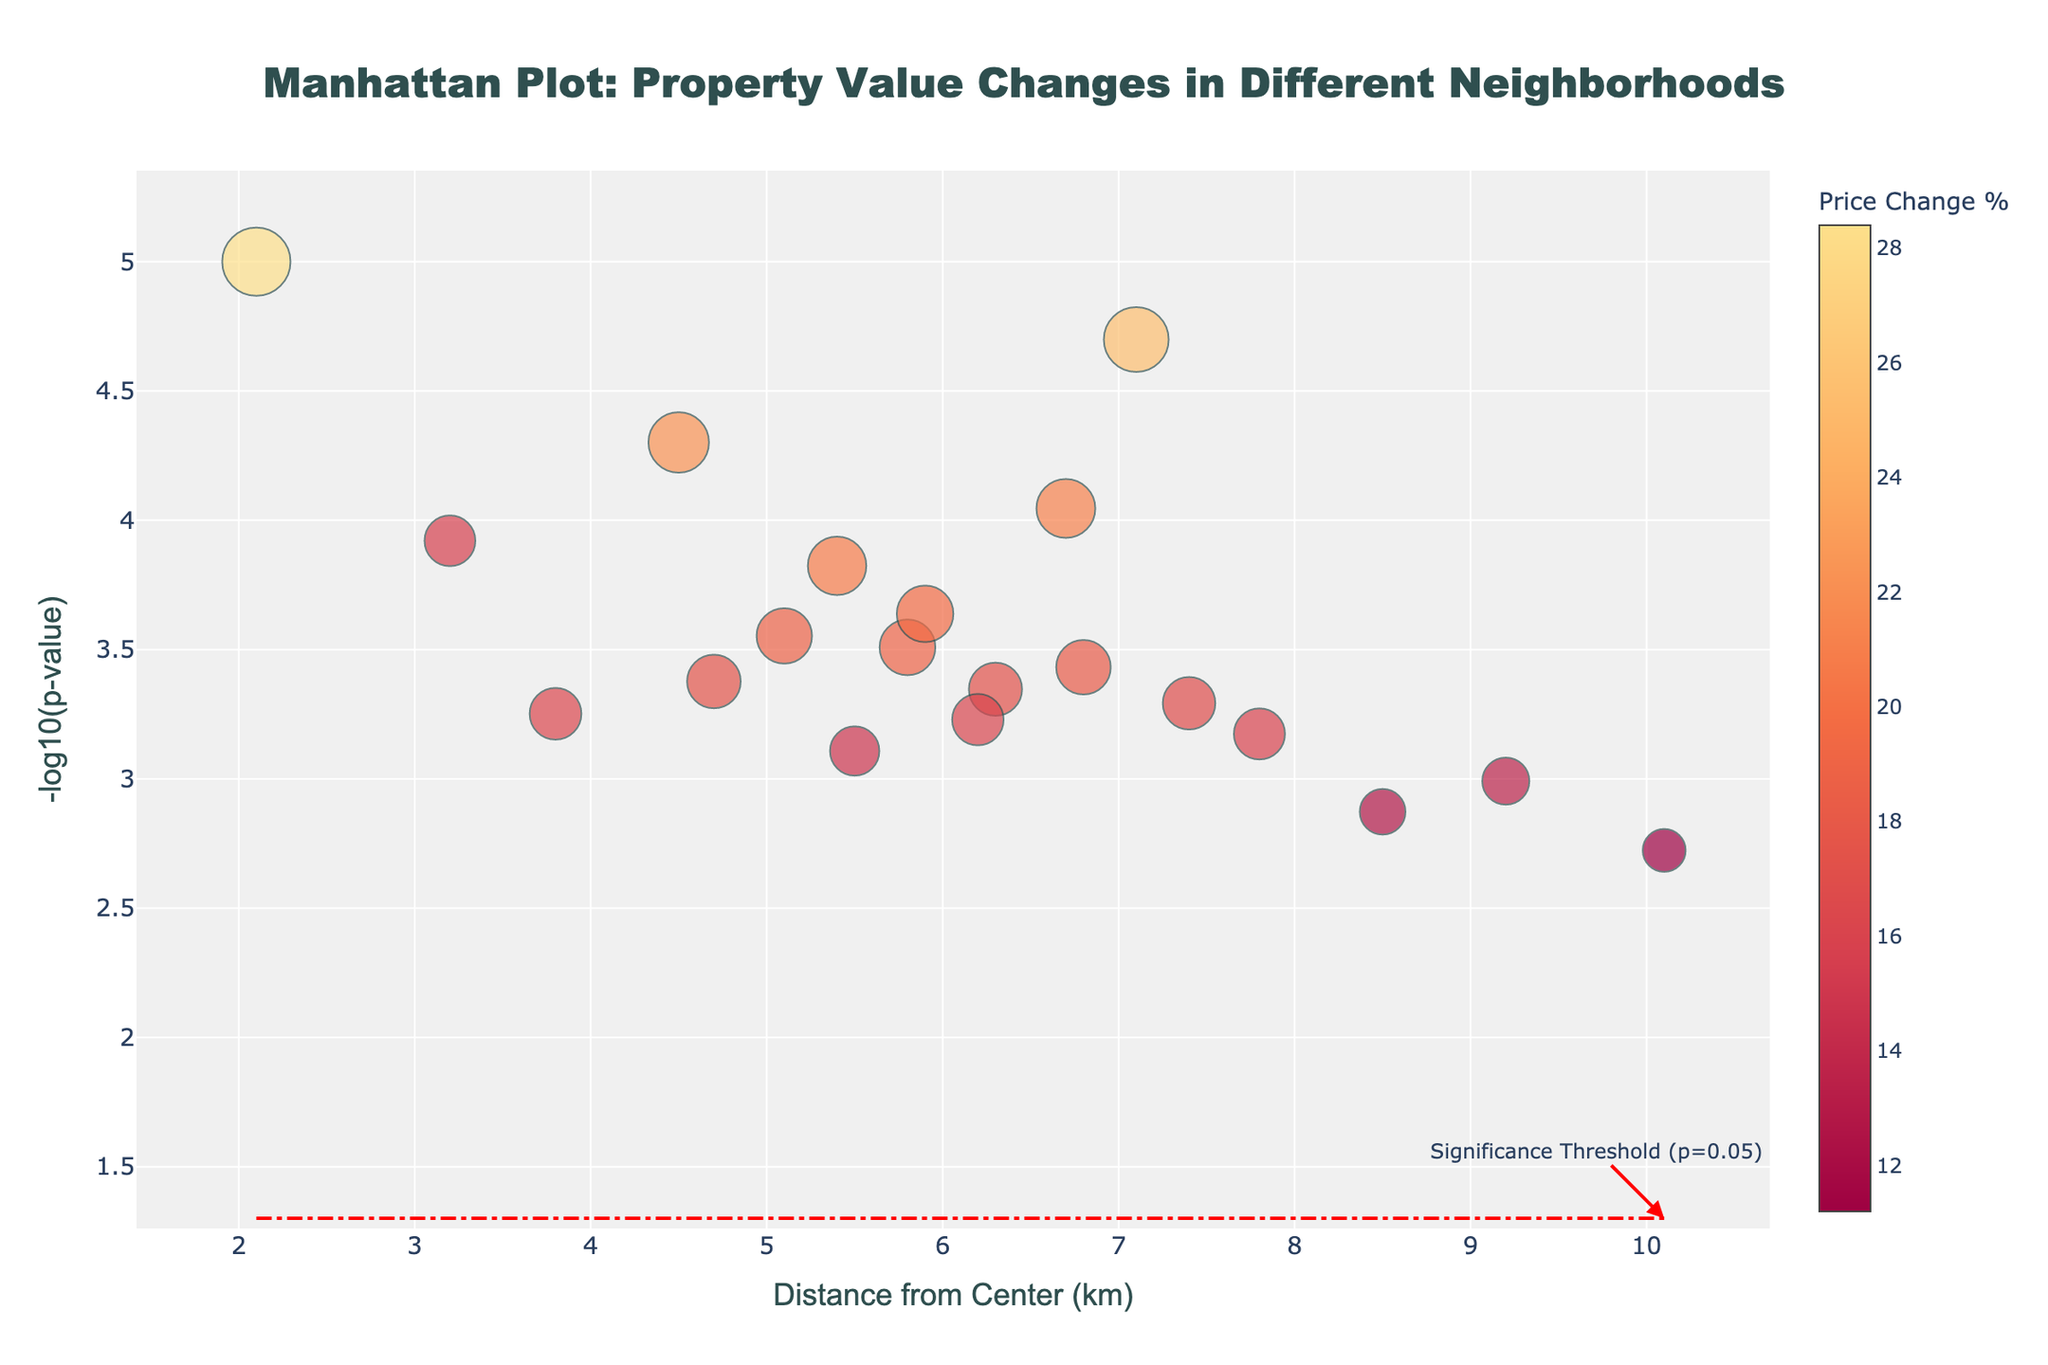What's the title of the plot? The title is located at the top of the plot and is usually in a larger font size. Here, it reads "Manhattan Plot: Property Value Changes in Different Neighborhoods".
Answer: Manhattan Plot: Property Value Changes in Different Neighborhoods How many data points are there in the plot? By looking at the plot, we can count the number of markers. Each marker represents a neighborhood.
Answer: 19 What is the significance threshold for the p-values in this plot? The plot includes a horizontal line that is labeled "Significance Threshold (p=0.05)". This line represents the -log10(p-value) threshold for significance.
Answer: p=0.05 Which neighborhood has experienced the highest percentage change in property values? By inspecting the markers and their corresponding hover text, we see that Long Island City has the highest price change percentage of 28.4%.
Answer: Long Island City How does the distance from the center relate to the property value change percentages overall? Observing the markers' placement and sizes across the plot, there isn't a clear linear relationship. Some neighborhoods far from the center have high changes, and some close ones have low changes and vice versa.
Answer: No clear linear relationship Which neighborhood's marker has the smallest size and what is its price change percentage? From the plot, the smallest marker corresponds to the smallest percentage change in property value, which we can identify by examining each marker's size and hover text. Howard Beach is the smallest with a price change of 11.2%.
Answer: Howard Beach, 11.2% What price change percentage is associated with significant p-values in this plot? Significant p-values are below the red threshold line at y = -log10(0.05). By checking the hover text of markers below this line, we find various price changes above this threshold.
Answer: 12.7% to 28.4% Which neighborhood, closest to the center within 4 km, has had the highest increase in property values? By focusing on markers within 4 km and checking their hover text, the highest percentage change closest to the center is Long Island City at 2.1 km with 28.4%.
Answer: Long Island City What is the -log10(p-value) of the most significant neighborhood, and what does it signify? The most significant neighborhood has the smallest p-value, represented by the highest -log10(p-value). Long Island City has the most significant value with the highest -log10(p-value).
Answer: Long Island City, high significance 